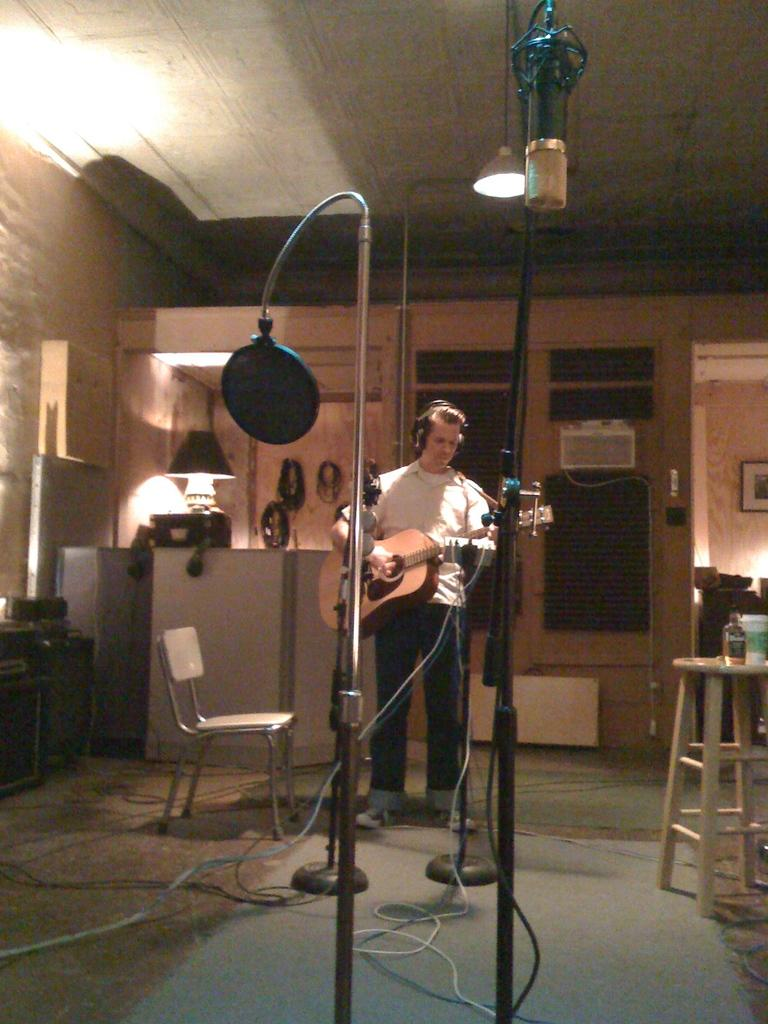What is the main subject of the image? There is a man in the image. Where is the man positioned in the image? The man is standing in the middle. What is the man doing in the image? The man is playing the guitar. What is the purpose of the voice filter in the image? The voice filter is present in the image, but its purpose is not clear from the facts provided. What piece of furniture is in the image? A chair is present in the image. What is the source of light in the image? There is a lamp beside the man. How many apples are on the ground in the image? There are no apples present in the image. Is the man playing the guitar in the park? The location of the image is not specified as a park, so we cannot determine if the man is playing the guitar in a park. 